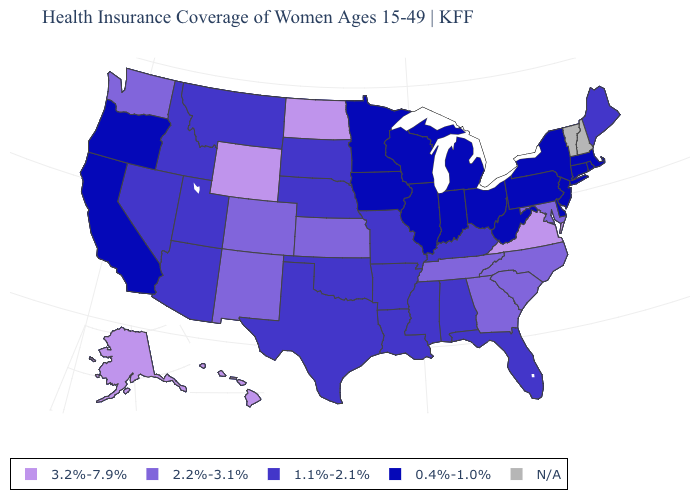What is the value of Colorado?
Write a very short answer. 2.2%-3.1%. What is the value of California?
Concise answer only. 0.4%-1.0%. Name the states that have a value in the range 1.1%-2.1%?
Give a very brief answer. Alabama, Arizona, Arkansas, Florida, Idaho, Kentucky, Louisiana, Maine, Mississippi, Missouri, Montana, Nebraska, Nevada, Oklahoma, South Dakota, Texas, Utah. What is the value of Hawaii?
Answer briefly. 3.2%-7.9%. Does Wyoming have the highest value in the USA?
Concise answer only. Yes. Name the states that have a value in the range N/A?
Concise answer only. New Hampshire, Vermont. Which states have the lowest value in the South?
Be succinct. Delaware, West Virginia. What is the value of Kansas?
Keep it brief. 2.2%-3.1%. What is the value of Oregon?
Keep it brief. 0.4%-1.0%. Which states have the highest value in the USA?
Give a very brief answer. Alaska, Hawaii, North Dakota, Virginia, Wyoming. Name the states that have a value in the range 0.4%-1.0%?
Answer briefly. California, Connecticut, Delaware, Illinois, Indiana, Iowa, Massachusetts, Michigan, Minnesota, New Jersey, New York, Ohio, Oregon, Pennsylvania, Rhode Island, West Virginia, Wisconsin. Does the map have missing data?
Keep it brief. Yes. What is the value of New Mexico?
Be succinct. 2.2%-3.1%. 